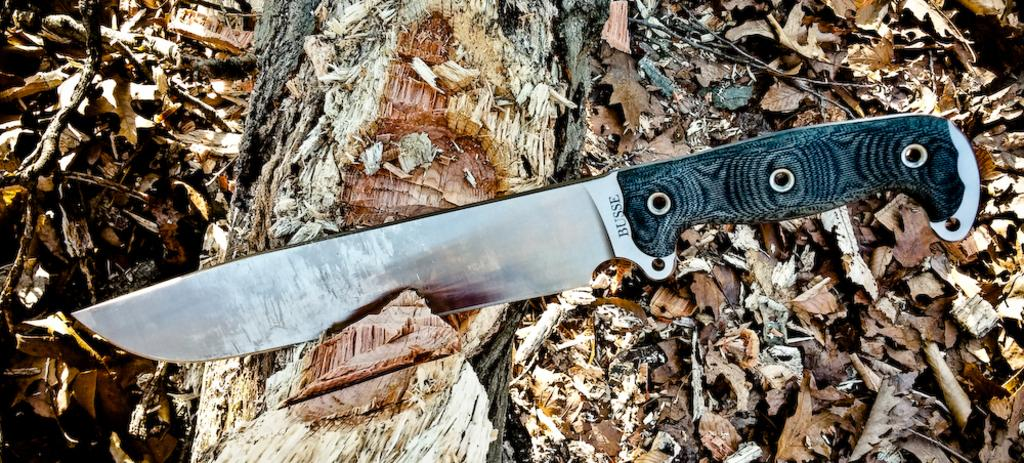What object can be seen in the image? There is a knife in the image. Where is the knife located? The knife is on a tree trunk. What can be seen in the background of the image? There are leaves visible in the background of the image. How many kittens are playing on the bed in the image? There are no kittens or beds present in the image; it features a knife on a tree trunk with leaves in the background. 